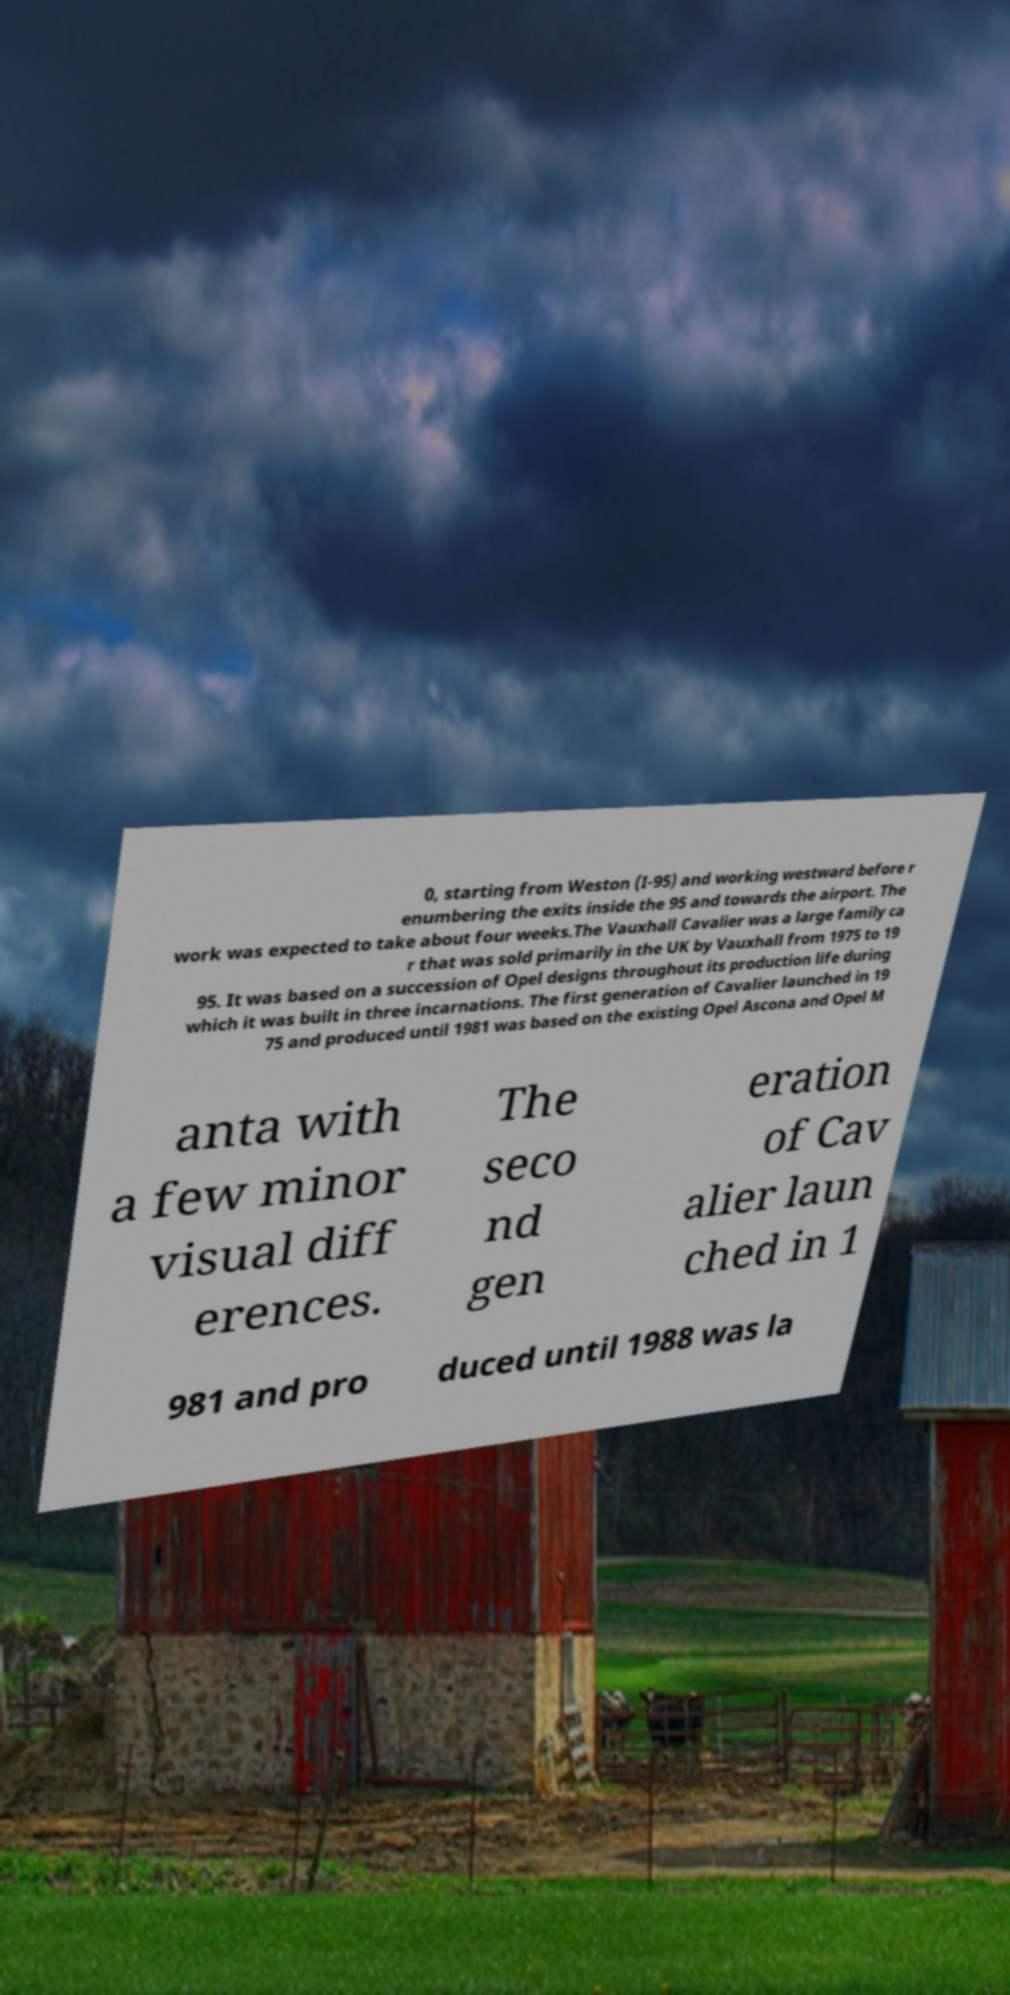What messages or text are displayed in this image? I need them in a readable, typed format. 0, starting from Weston (I-95) and working westward before r enumbering the exits inside the 95 and towards the airport. The work was expected to take about four weeks.The Vauxhall Cavalier was a large family ca r that was sold primarily in the UK by Vauxhall from 1975 to 19 95. It was based on a succession of Opel designs throughout its production life during which it was built in three incarnations. The first generation of Cavalier launched in 19 75 and produced until 1981 was based on the existing Opel Ascona and Opel M anta with a few minor visual diff erences. The seco nd gen eration of Cav alier laun ched in 1 981 and pro duced until 1988 was la 